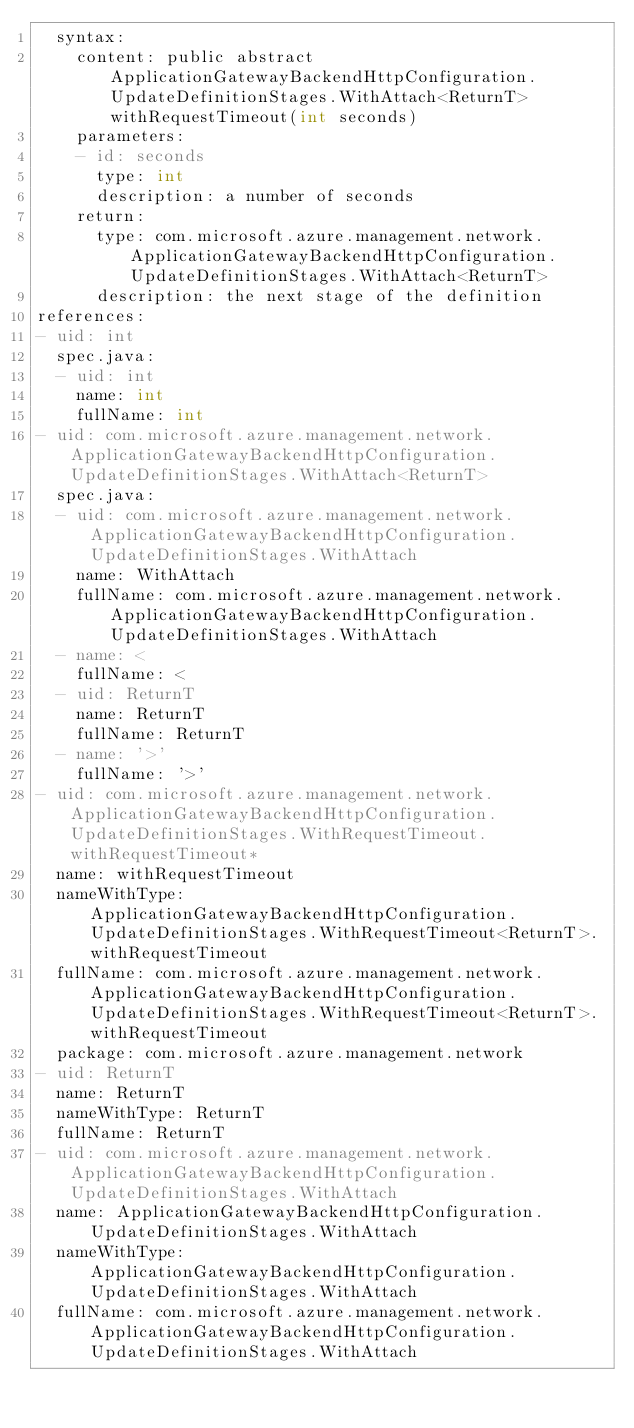<code> <loc_0><loc_0><loc_500><loc_500><_YAML_>  syntax:
    content: public abstract ApplicationGatewayBackendHttpConfiguration.UpdateDefinitionStages.WithAttach<ReturnT> withRequestTimeout(int seconds)
    parameters:
    - id: seconds
      type: int
      description: a number of seconds
    return:
      type: com.microsoft.azure.management.network.ApplicationGatewayBackendHttpConfiguration.UpdateDefinitionStages.WithAttach<ReturnT>
      description: the next stage of the definition
references:
- uid: int
  spec.java:
  - uid: int
    name: int
    fullName: int
- uid: com.microsoft.azure.management.network.ApplicationGatewayBackendHttpConfiguration.UpdateDefinitionStages.WithAttach<ReturnT>
  spec.java:
  - uid: com.microsoft.azure.management.network.ApplicationGatewayBackendHttpConfiguration.UpdateDefinitionStages.WithAttach
    name: WithAttach
    fullName: com.microsoft.azure.management.network.ApplicationGatewayBackendHttpConfiguration.UpdateDefinitionStages.WithAttach
  - name: <
    fullName: <
  - uid: ReturnT
    name: ReturnT
    fullName: ReturnT
  - name: '>'
    fullName: '>'
- uid: com.microsoft.azure.management.network.ApplicationGatewayBackendHttpConfiguration.UpdateDefinitionStages.WithRequestTimeout.withRequestTimeout*
  name: withRequestTimeout
  nameWithType: ApplicationGatewayBackendHttpConfiguration.UpdateDefinitionStages.WithRequestTimeout<ReturnT>.withRequestTimeout
  fullName: com.microsoft.azure.management.network.ApplicationGatewayBackendHttpConfiguration.UpdateDefinitionStages.WithRequestTimeout<ReturnT>.withRequestTimeout
  package: com.microsoft.azure.management.network
- uid: ReturnT
  name: ReturnT
  nameWithType: ReturnT
  fullName: ReturnT
- uid: com.microsoft.azure.management.network.ApplicationGatewayBackendHttpConfiguration.UpdateDefinitionStages.WithAttach
  name: ApplicationGatewayBackendHttpConfiguration.UpdateDefinitionStages.WithAttach
  nameWithType: ApplicationGatewayBackendHttpConfiguration.UpdateDefinitionStages.WithAttach
  fullName: com.microsoft.azure.management.network.ApplicationGatewayBackendHttpConfiguration.UpdateDefinitionStages.WithAttach
</code> 